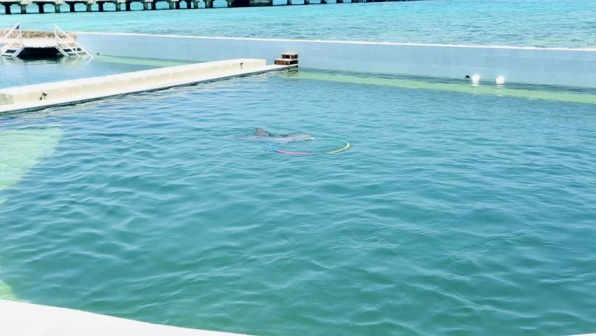What do you think happened just before this photo was taken? Just before this photo was taken, the dolphin might have been engaged in playful activity such as swimming quickly through the water or interacting with objects like rings and buoys. Perhaps it was part of a training session or a public demonstration, and it had just performed a jump or a trick, attracting the attention of both onlookers and the photographer. The dolphin might also have been swimming around leisurely, enjoying a calm moment before resuming its more active behaviors. The peaceful setting of the water and the presence of the facilities suggest that any preceding activity was well-organized and part of a daily routine meant to ensure the dolphin's well-being and stimulation. 